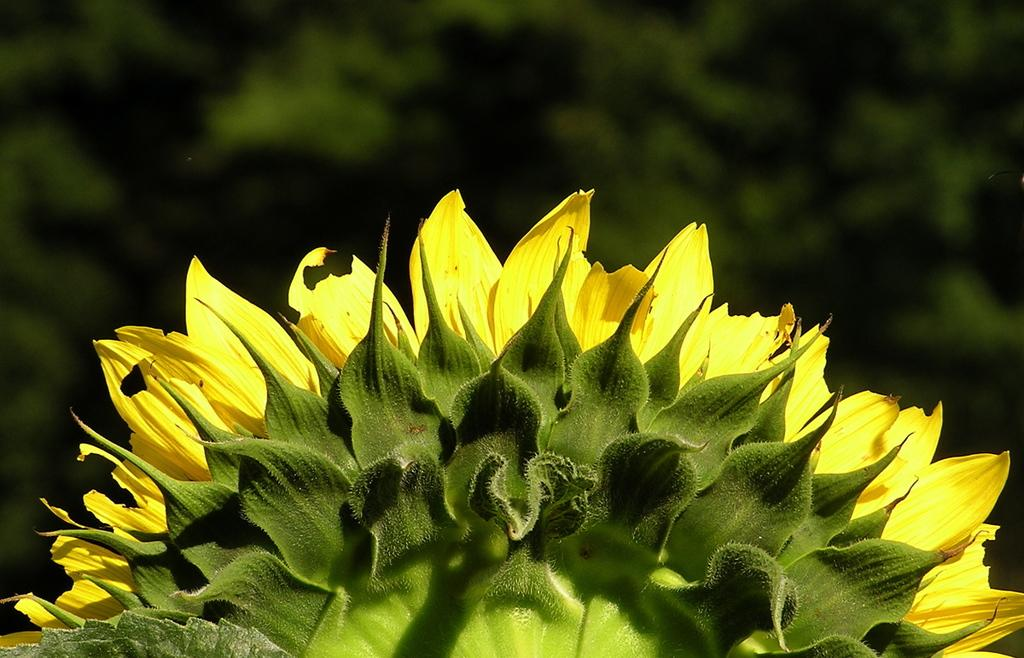What type of plant is in the image? There is a sunflower in the image. What colors can be seen on the sunflower? The sunflower has yellow and green colors. How would you describe the background of the image? The background of the image is blurred. What type of mint can be seen growing next to the sunflower in the image? There is no mint present in the image; it only features a sunflower. 